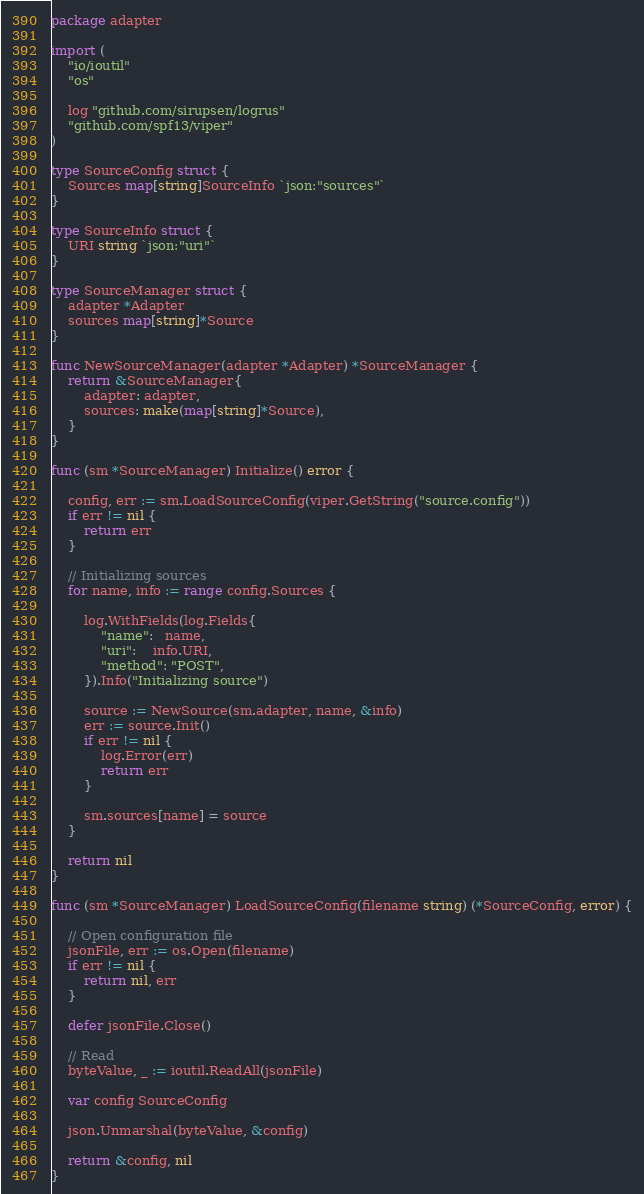Convert code to text. <code><loc_0><loc_0><loc_500><loc_500><_Go_>package adapter

import (
	"io/ioutil"
	"os"

	log "github.com/sirupsen/logrus"
	"github.com/spf13/viper"
)

type SourceConfig struct {
	Sources map[string]SourceInfo `json:"sources"`
}

type SourceInfo struct {
	URI string `json:"uri"`
}

type SourceManager struct {
	adapter *Adapter
	sources map[string]*Source
}

func NewSourceManager(adapter *Adapter) *SourceManager {
	return &SourceManager{
		adapter: adapter,
		sources: make(map[string]*Source),
	}
}

func (sm *SourceManager) Initialize() error {

	config, err := sm.LoadSourceConfig(viper.GetString("source.config"))
	if err != nil {
		return err
	}

	// Initializing sources
	for name, info := range config.Sources {

		log.WithFields(log.Fields{
			"name":   name,
			"uri":    info.URI,
			"method": "POST",
		}).Info("Initializing source")

		source := NewSource(sm.adapter, name, &info)
		err := source.Init()
		if err != nil {
			log.Error(err)
			return err
		}

		sm.sources[name] = source
	}

	return nil
}

func (sm *SourceManager) LoadSourceConfig(filename string) (*SourceConfig, error) {

	// Open configuration file
	jsonFile, err := os.Open(filename)
	if err != nil {
		return nil, err
	}

	defer jsonFile.Close()

	// Read
	byteValue, _ := ioutil.ReadAll(jsonFile)

	var config SourceConfig

	json.Unmarshal(byteValue, &config)

	return &config, nil
}
</code> 